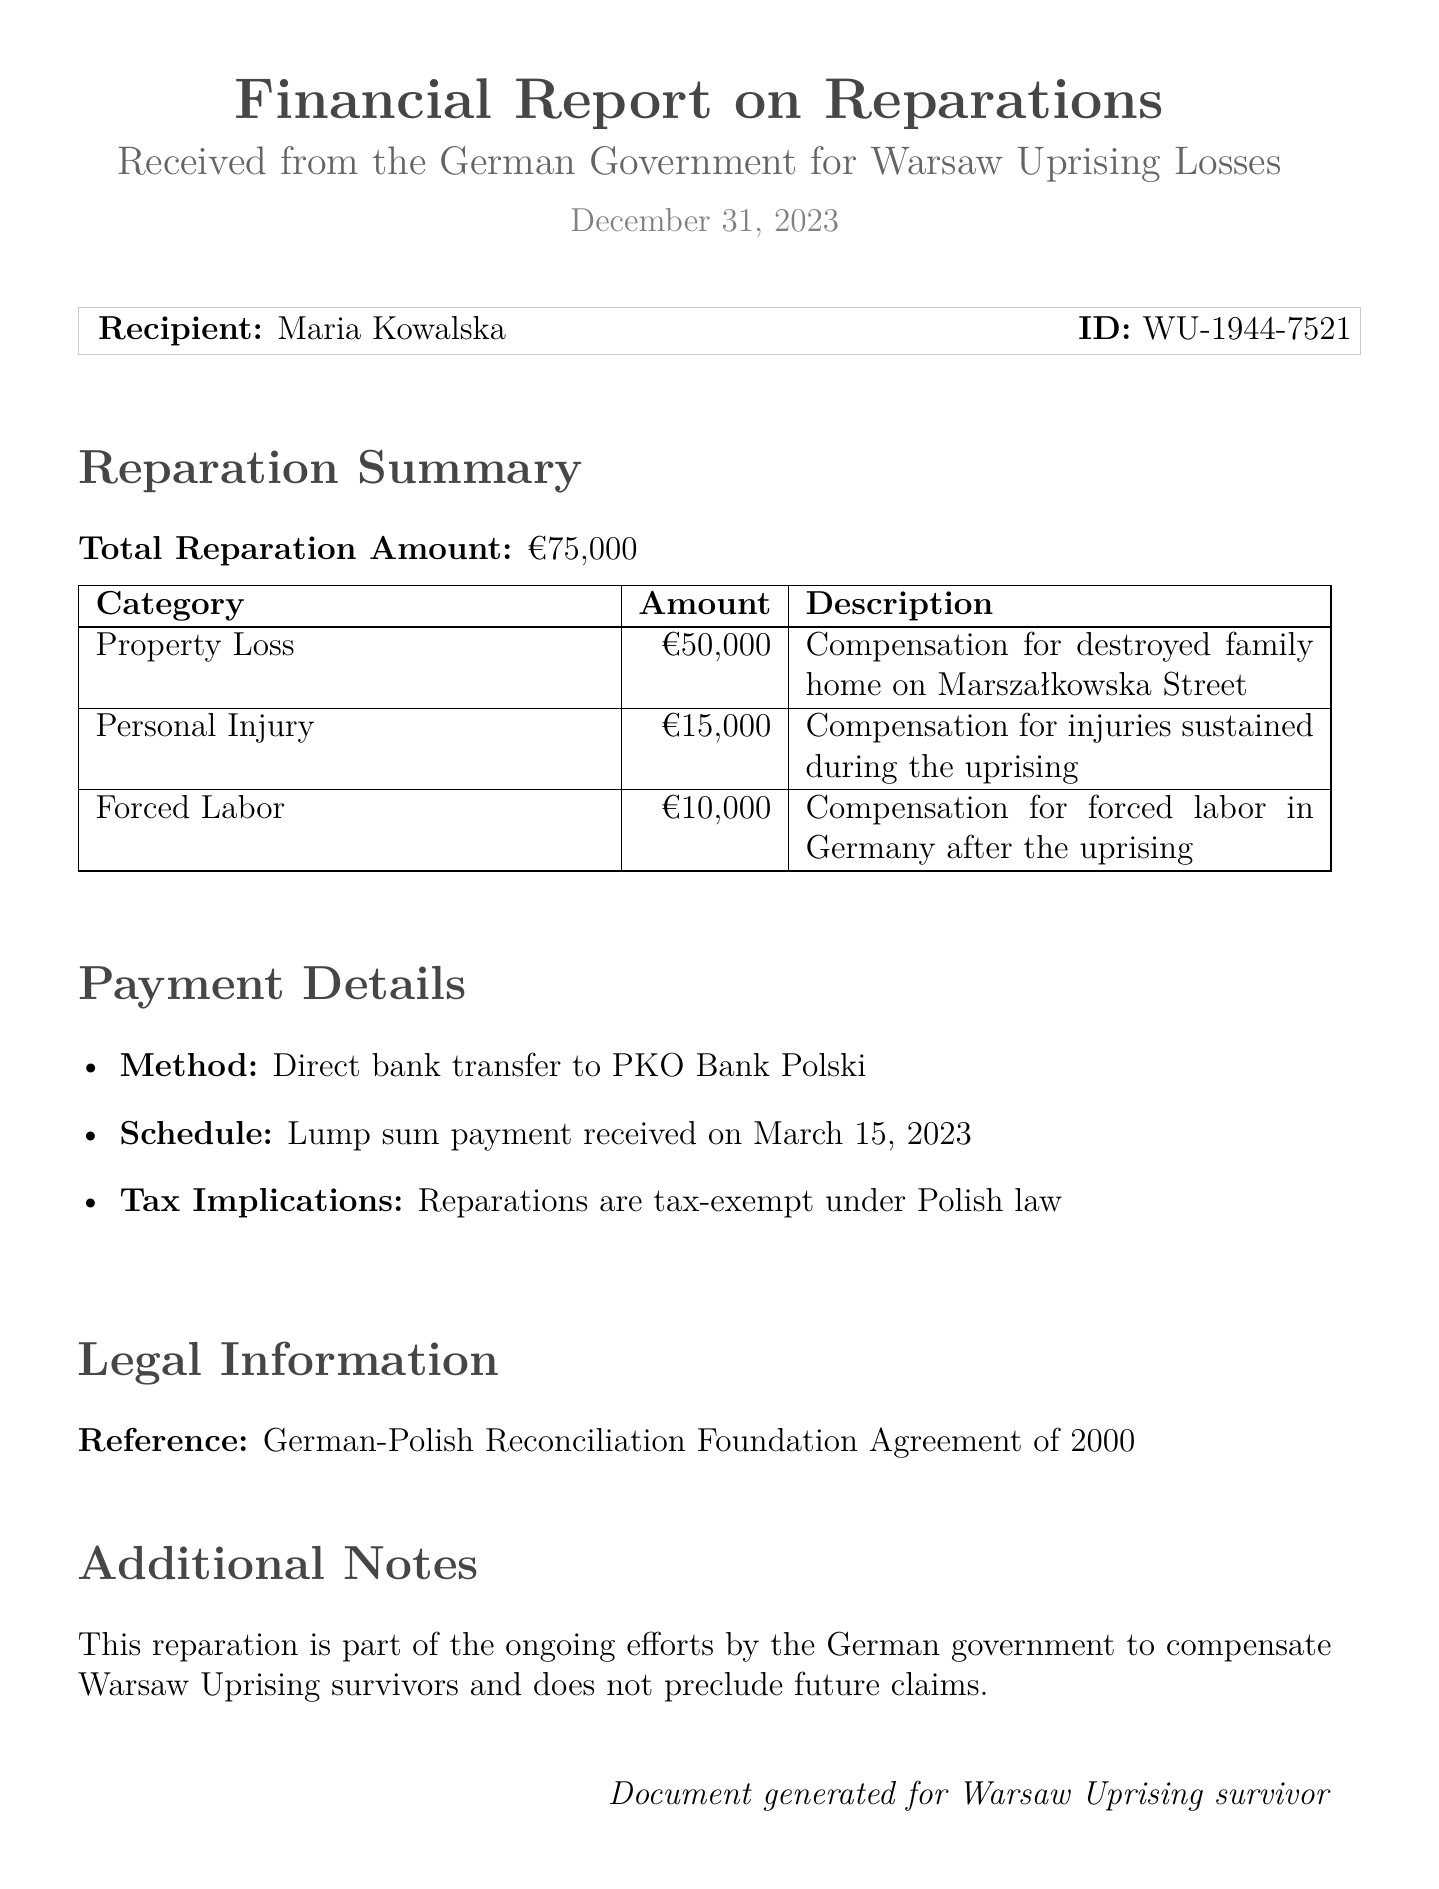What is the total reparation amount? The total reparation amount is stated in the report as €75,000.
Answer: €75,000 What category received the highest compensation? The category with the highest compensation is Property Loss with an amount of €50,000.
Answer: Property Loss When was the payment received? The payment schedule specifies that the lump sum payment was received on March 15, 2023.
Answer: March 15, 2023 Is the reparation amount taxable? The report notes that reparations are tax-exempt under Polish law, indicating they are not taxable.
Answer: Tax-exempt What was the payment method? The payment method mentioned in the report is a direct bank transfer to PKO Bank Polski.
Answer: Direct bank transfer to PKO Bank Polski What is the legal reference cited in the report? The report cites the German-Polish Reconciliation Foundation Agreement of 2000 as the legal reference.
Answer: German-Polish Reconciliation Foundation Agreement of 2000 How much compensation was received for personal injury? The report specifies that the compensation for personal injury amounts to €15,000.
Answer: €15,000 What additional information is provided regarding future claims? The report mentions that the reparation does not preclude future claims against the German government.
Answer: Does not preclude future claims 